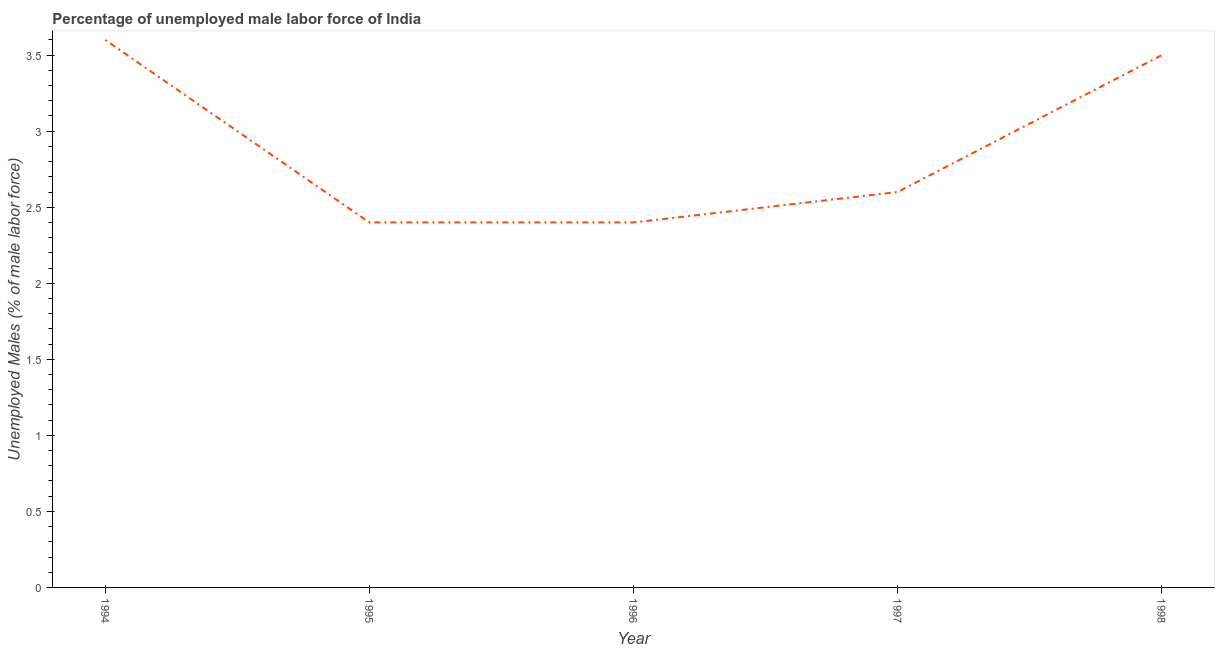What is the total unemployed male labour force in 1995?
Your answer should be very brief. 2.4. Across all years, what is the maximum total unemployed male labour force?
Your response must be concise. 3.6. Across all years, what is the minimum total unemployed male labour force?
Your answer should be very brief. 2.4. In which year was the total unemployed male labour force maximum?
Provide a succinct answer. 1994. In which year was the total unemployed male labour force minimum?
Your answer should be compact. 1995. What is the difference between the total unemployed male labour force in 1995 and 1997?
Give a very brief answer. -0.2. What is the average total unemployed male labour force per year?
Your answer should be compact. 2.9. What is the median total unemployed male labour force?
Ensure brevity in your answer.  2.6. Do a majority of the years between 1996 and 1997 (inclusive) have total unemployed male labour force greater than 3.2 %?
Your answer should be very brief. No. What is the difference between the highest and the second highest total unemployed male labour force?
Your answer should be compact. 0.1. What is the difference between the highest and the lowest total unemployed male labour force?
Your answer should be compact. 1.2. In how many years, is the total unemployed male labour force greater than the average total unemployed male labour force taken over all years?
Your response must be concise. 2. How many lines are there?
Offer a very short reply. 1. What is the difference between two consecutive major ticks on the Y-axis?
Offer a very short reply. 0.5. Does the graph contain any zero values?
Your answer should be compact. No. Does the graph contain grids?
Offer a very short reply. No. What is the title of the graph?
Your response must be concise. Percentage of unemployed male labor force of India. What is the label or title of the X-axis?
Keep it short and to the point. Year. What is the label or title of the Y-axis?
Provide a succinct answer. Unemployed Males (% of male labor force). What is the Unemployed Males (% of male labor force) of 1994?
Make the answer very short. 3.6. What is the Unemployed Males (% of male labor force) of 1995?
Give a very brief answer. 2.4. What is the Unemployed Males (% of male labor force) of 1996?
Make the answer very short. 2.4. What is the Unemployed Males (% of male labor force) in 1997?
Provide a succinct answer. 2.6. What is the difference between the Unemployed Males (% of male labor force) in 1994 and 1996?
Your response must be concise. 1.2. What is the difference between the Unemployed Males (% of male labor force) in 1995 and 1997?
Your answer should be very brief. -0.2. What is the difference between the Unemployed Males (% of male labor force) in 1995 and 1998?
Provide a succinct answer. -1.1. What is the ratio of the Unemployed Males (% of male labor force) in 1994 to that in 1996?
Your response must be concise. 1.5. What is the ratio of the Unemployed Males (% of male labor force) in 1994 to that in 1997?
Your answer should be very brief. 1.39. What is the ratio of the Unemployed Males (% of male labor force) in 1994 to that in 1998?
Your answer should be very brief. 1.03. What is the ratio of the Unemployed Males (% of male labor force) in 1995 to that in 1996?
Your answer should be compact. 1. What is the ratio of the Unemployed Males (% of male labor force) in 1995 to that in 1997?
Provide a succinct answer. 0.92. What is the ratio of the Unemployed Males (% of male labor force) in 1995 to that in 1998?
Provide a succinct answer. 0.69. What is the ratio of the Unemployed Males (% of male labor force) in 1996 to that in 1997?
Offer a very short reply. 0.92. What is the ratio of the Unemployed Males (% of male labor force) in 1996 to that in 1998?
Offer a very short reply. 0.69. What is the ratio of the Unemployed Males (% of male labor force) in 1997 to that in 1998?
Your answer should be compact. 0.74. 